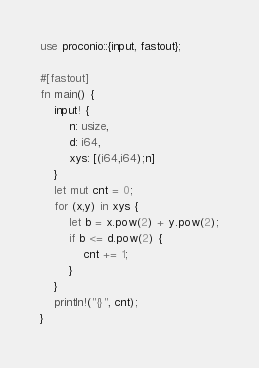<code> <loc_0><loc_0><loc_500><loc_500><_Rust_>use proconio::{input, fastout};

#[fastout]
fn main() {
    input! {
        n: usize,
        d: i64,
        xys: [(i64,i64);n]
    }
    let mut cnt = 0;
    for (x,y) in xys {
        let b = x.pow(2) + y.pow(2);
        if b <= d.pow(2) {
            cnt += 1;
        }
    }
    println!("{}", cnt);
}
</code> 